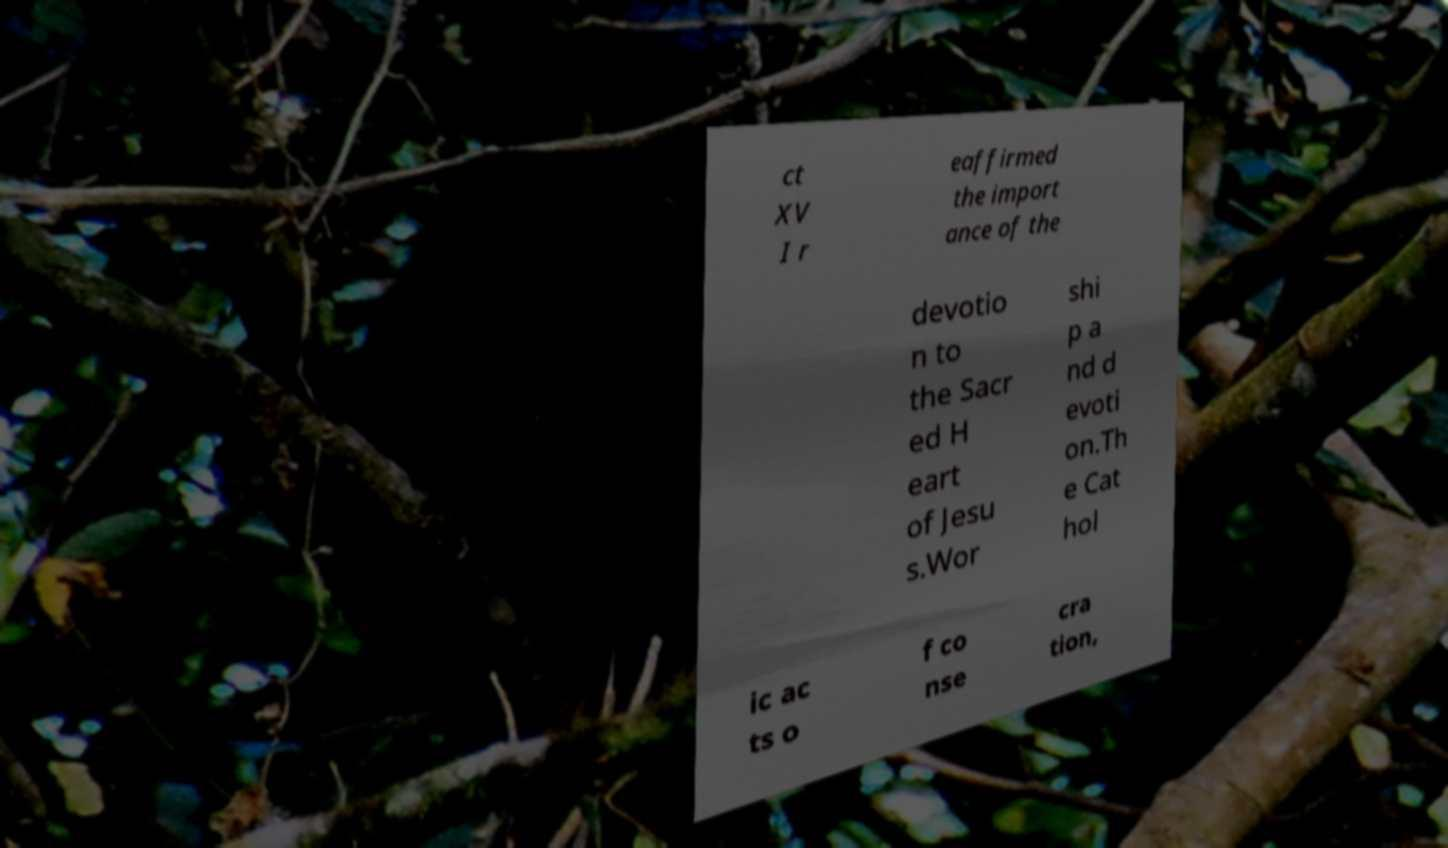Please read and relay the text visible in this image. What does it say? ct XV I r eaffirmed the import ance of the devotio n to the Sacr ed H eart of Jesu s.Wor shi p a nd d evoti on.Th e Cat hol ic ac ts o f co nse cra tion, 